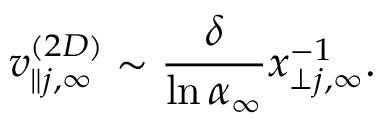<formula> <loc_0><loc_0><loc_500><loc_500>v _ { \| j , \infty } ^ { ( 2 D ) } \sim \frac { \delta } { \ln \alpha _ { \infty } } x _ { \perp j , \infty } ^ { - 1 } .</formula> 